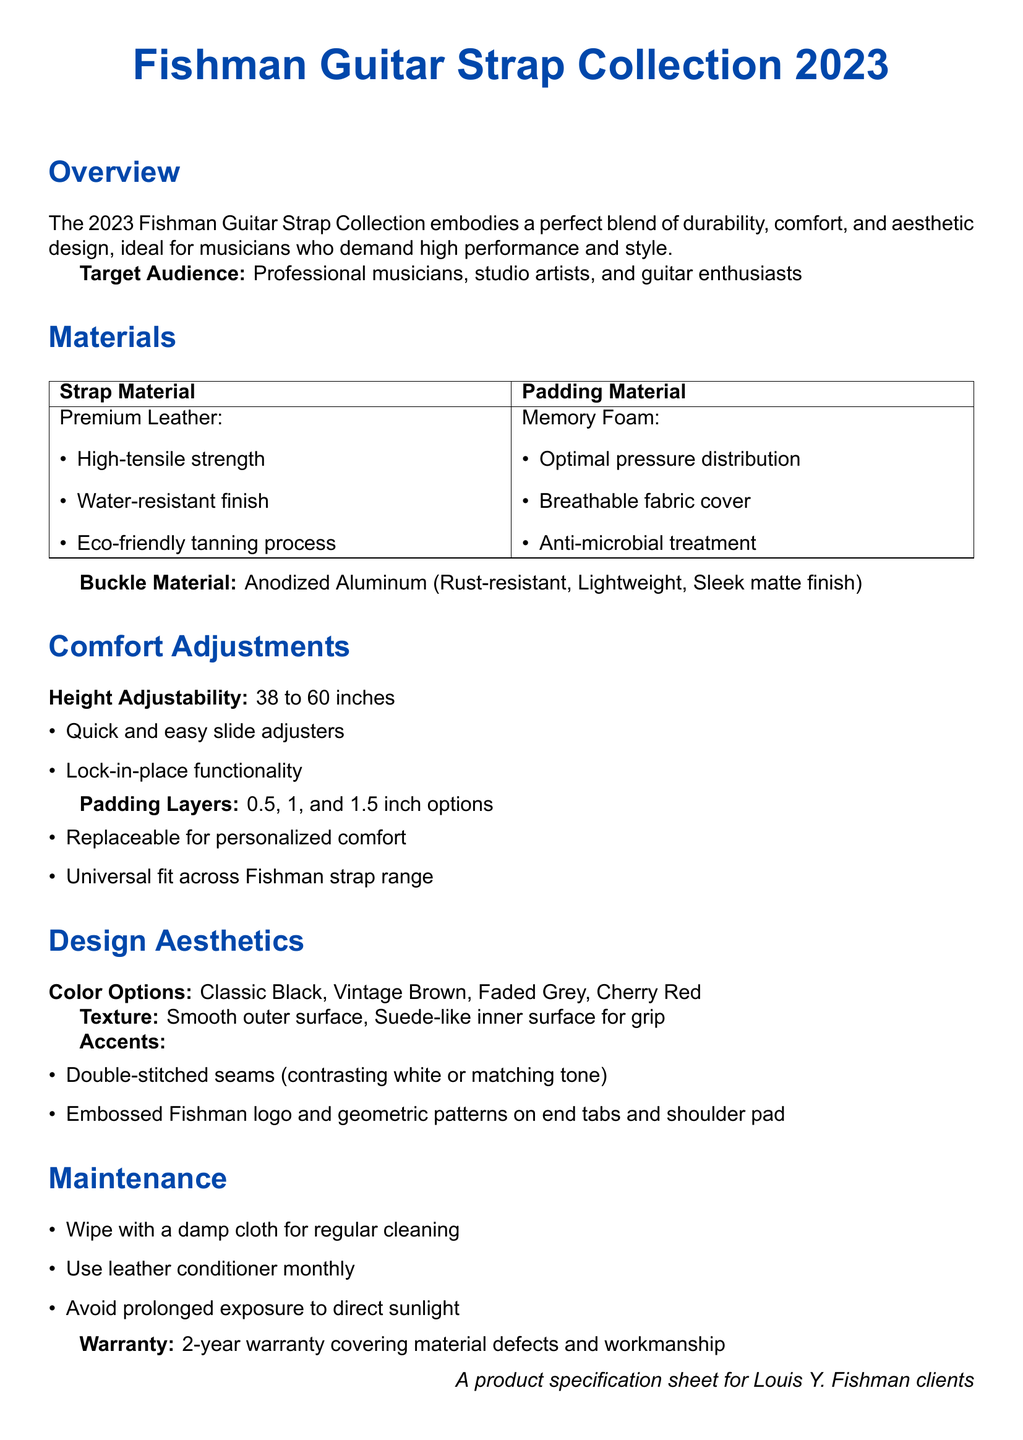What materials are used for the strap? The strap is made of Premium Leather and the padding is made of Memory Foam.
Answer: Premium Leather, Memory Foam What is the height adjustability range of the strap? The height can be adjusted from 38 to 60 inches according to the specifications provided.
Answer: 38 to 60 inches What padding layer options are available? The document lists three options for padding layers, which are 0.5, 1, and 1.5 inches.
Answer: 0.5, 1, and 1.5 inches Which material is used for the buckle? The buckle is specified to be made of anodized aluminum, known for its properties.
Answer: Anodized Aluminum What are the color options available for the straps? The document highlights several colors, including Classic Black, Vintage Brown, Faded Grey, and Cherry Red.
Answer: Classic Black, Vintage Brown, Faded Grey, Cherry Red How often should leather conditioner be used for maintenance? The maintenance section mentions that leather conditioner should be used monthly for optimal upkeep.
Answer: Monthly What type of treatment does the padding material have? The padding material has an anti-microbial treatment, which is specified in the materials section.
Answer: Anti-microbial treatment What design feature is included for grip? The product features a suede-like inner surface to enhance grip.
Answer: Suede-like inner surface What warranty period is offered for the strap? The warranty for material defects and workmanship is noted to be two years.
Answer: 2-year warranty 